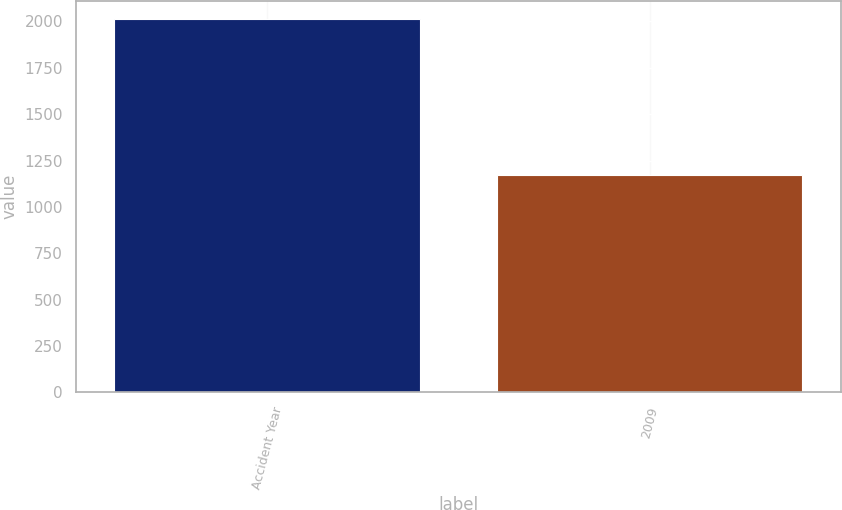Convert chart to OTSL. <chart><loc_0><loc_0><loc_500><loc_500><bar_chart><fcel>Accident Year<fcel>2009<nl><fcel>2012<fcel>1171<nl></chart> 